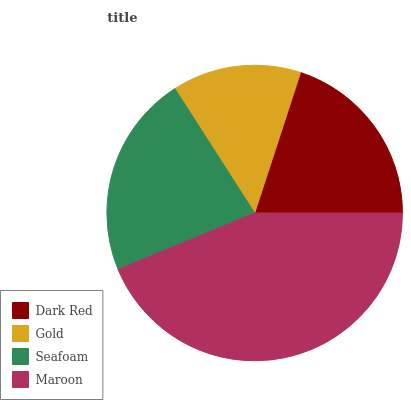Is Gold the minimum?
Answer yes or no. Yes. Is Maroon the maximum?
Answer yes or no. Yes. Is Seafoam the minimum?
Answer yes or no. No. Is Seafoam the maximum?
Answer yes or no. No. Is Seafoam greater than Gold?
Answer yes or no. Yes. Is Gold less than Seafoam?
Answer yes or no. Yes. Is Gold greater than Seafoam?
Answer yes or no. No. Is Seafoam less than Gold?
Answer yes or no. No. Is Seafoam the high median?
Answer yes or no. Yes. Is Dark Red the low median?
Answer yes or no. Yes. Is Maroon the high median?
Answer yes or no. No. Is Seafoam the low median?
Answer yes or no. No. 